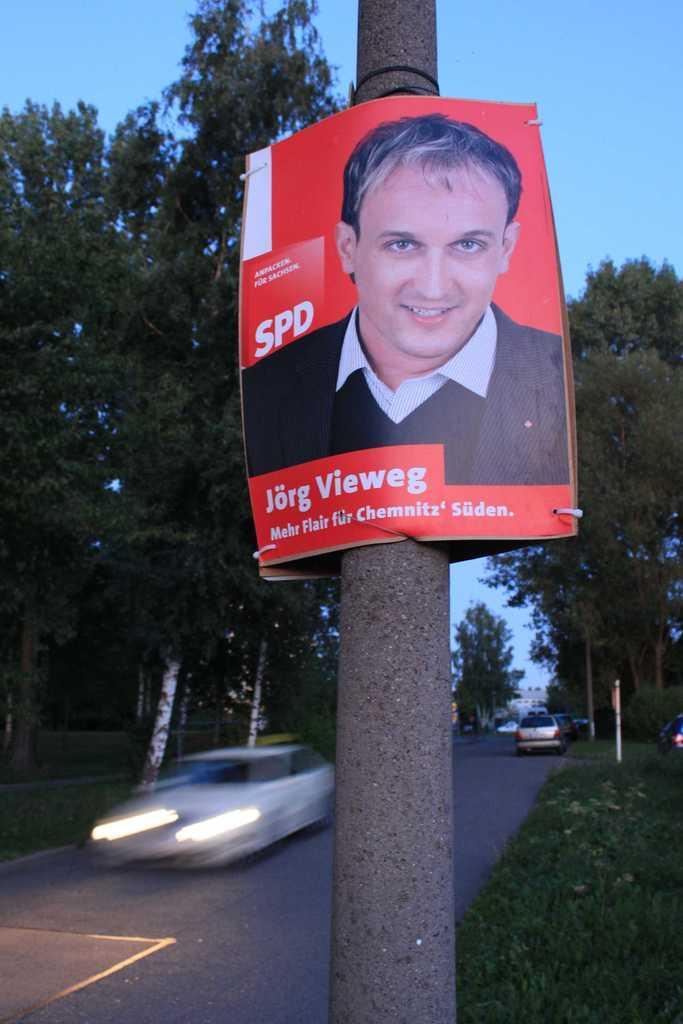Describe this image in one or two sentences. In the foreground of this image, there is a poster on a pole. In the background, there are trees, grass, vehicles on the road and the sky at the top. 